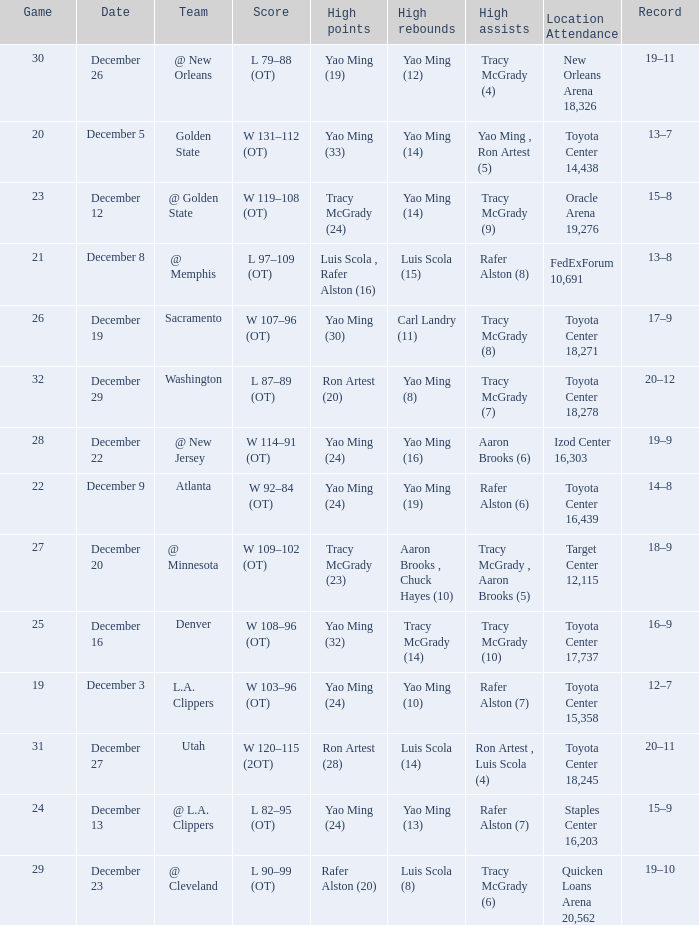When tracy mcgrady (8) is leading in assists what is the date? December 19. 